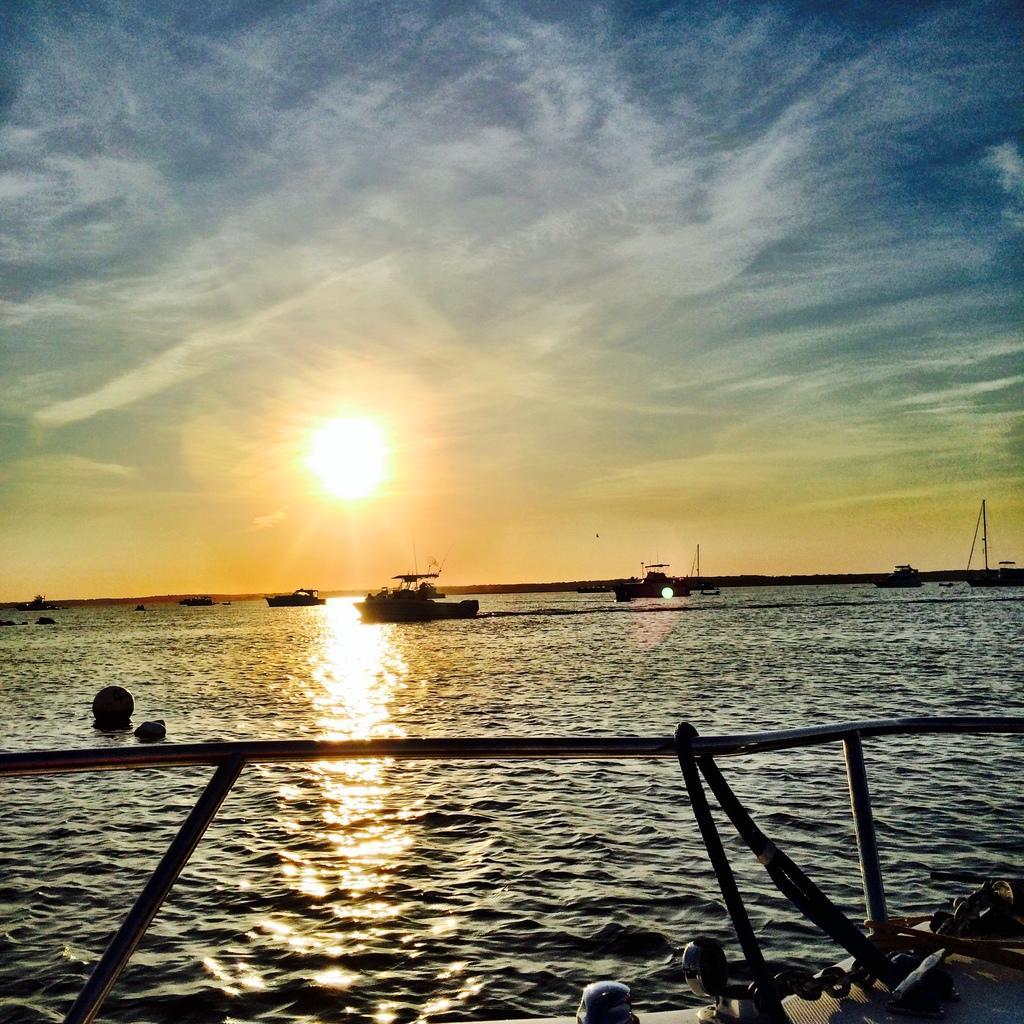Please provide a concise description of this image. There are boats present on the surface of water as we can see at the bottom of this image. We can see a sun in the middle of this image and the sky is in the background. 